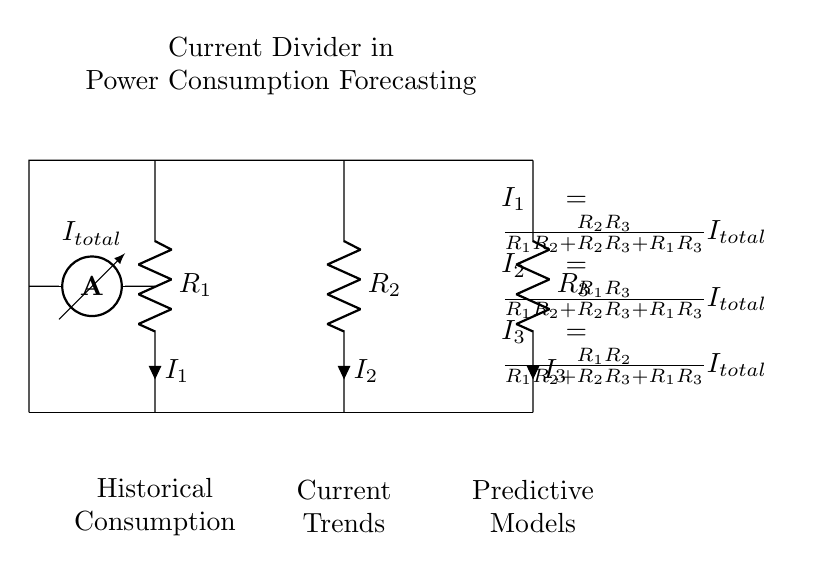What is the total current in the circuit? The total current \( I_{total} \) can be inferred directly from the ammeter symbol shown in the diagram, which indicates it is measuring the total current flowing into the parallel resistors.
Answer: I total What are the resistances in the circuit? The circuit shows three resistors labeled \( R_1 \), \( R_2 \), and \( R_3 \). The respective resistances can be determined by identifying their labels in the diagram.
Answer: R1, R2, R3 Which component has the highest current? To determine which component has the highest current, we compare the formulas for \( I_1 \), \( I_2 \), and \( I_3 \). Since these currents depend on the values of the resistors, the current flowing through the resistor with the lowest resistance will be the highest.
Answer: R with lowest resistance How does the current distribute among the resistors? The formulas provided in the diagram show how the total current \( I_{total} \) is divided between the resistors based on their resistances. Each current is a fraction of the total current influenced by resistor values, showing the principle of the current divider.
Answer: Based on resistances What does each current formula indicate about the resistors? Each formula \( I_1 \), \( I_2 \), and \( I_3 \) represents the relationship between the resistance of each resistor and the total current. It illustrates that the currents through the resistors are inversely proportional to their resistances within the current divider configuration.
Answer: Inversely proportional What principle does a current divider illustrate? A current divider illustrates the principle of how current divides into multiple paths in a parallel circuit, where the current is distributed based on the resistance values of each path. This concept is crucial in electrical engineering and power consumption forecasting models.
Answer: Current division How would changing \( R_2 \) affect \( I_2 \)? Changing \( R_2 \) would alter its contribution to the calculation of \( I_2 \) as shown in its formula. Specifically, reducing \( R_2 \) would increase \( I_2 \) due to its inverse relationship with respect to \( R_2 \).
Answer: Increases with decrease 